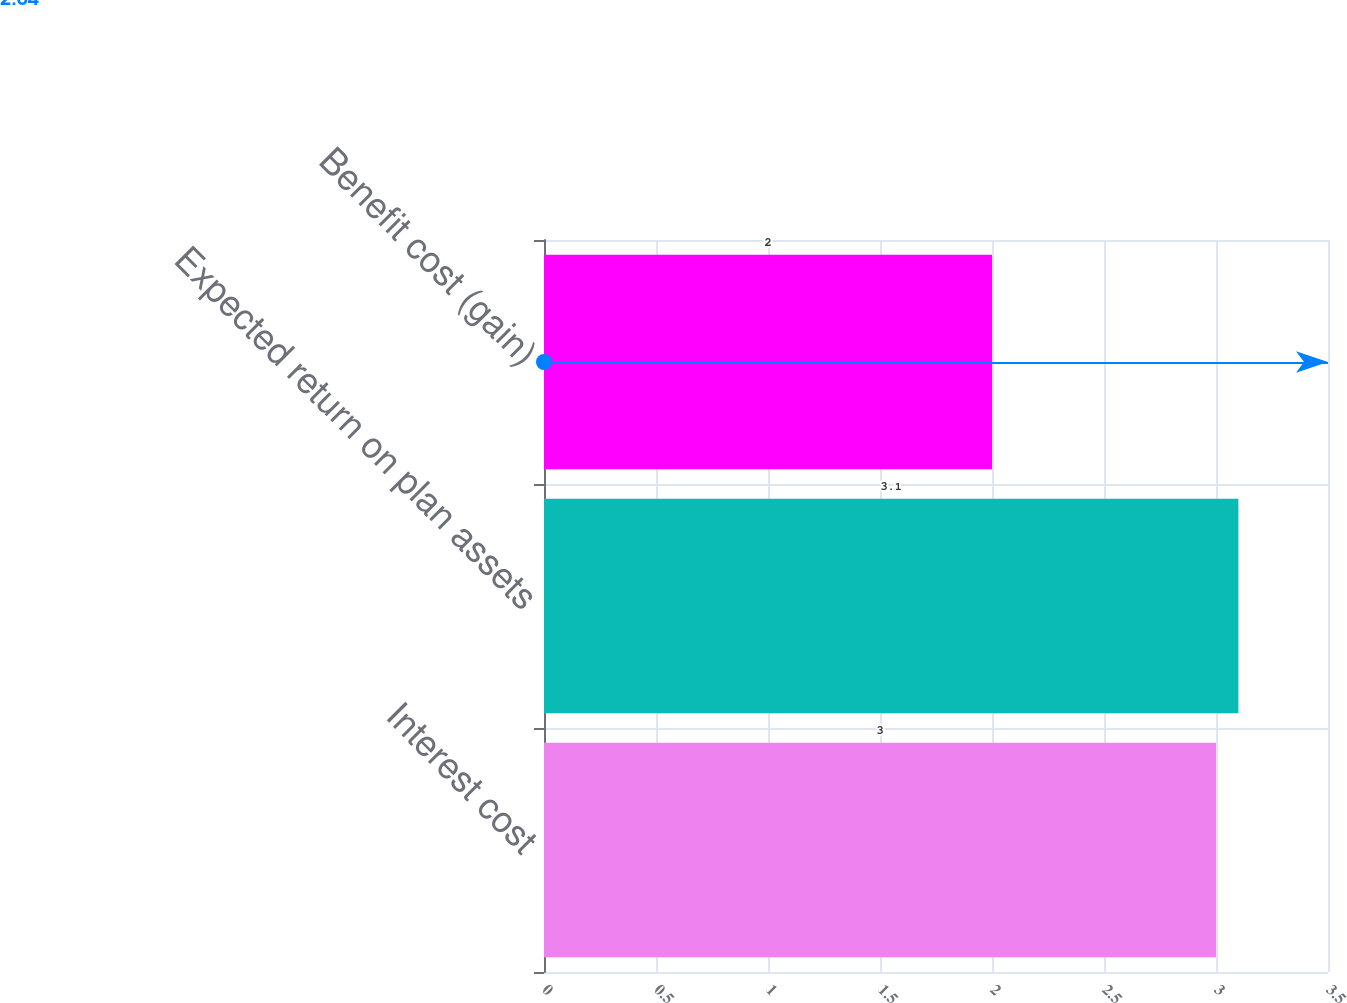<chart> <loc_0><loc_0><loc_500><loc_500><bar_chart><fcel>Interest cost<fcel>Expected return on plan assets<fcel>Benefit cost (gain)<nl><fcel>3<fcel>3.1<fcel>2<nl></chart> 